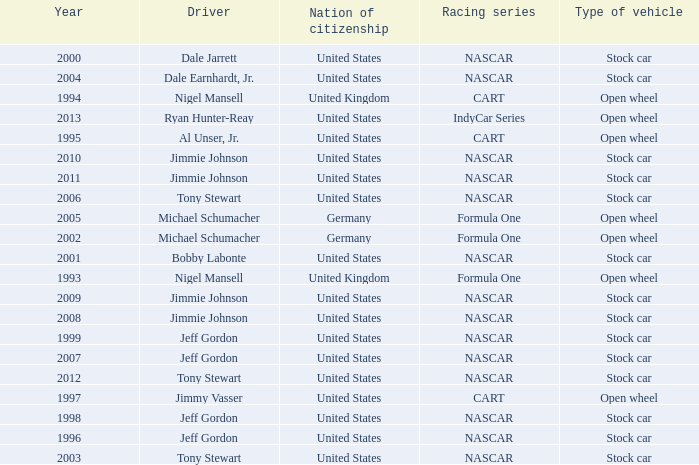What year has the vehicle of open wheel and a racing series of formula one with a Nation of citizenship in Germany. 2002, 2005. 